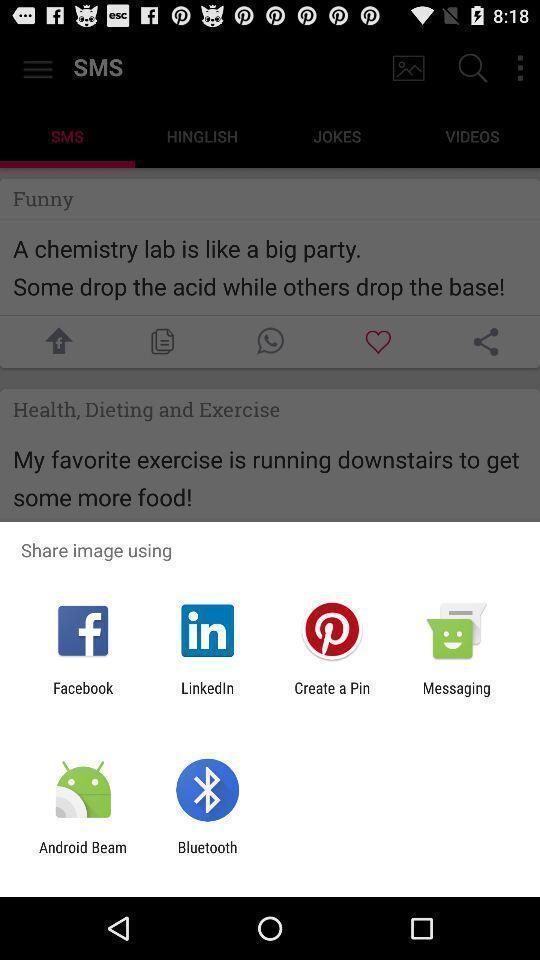Describe the key features of this screenshot. Pop-up with multiple image sharing options. 